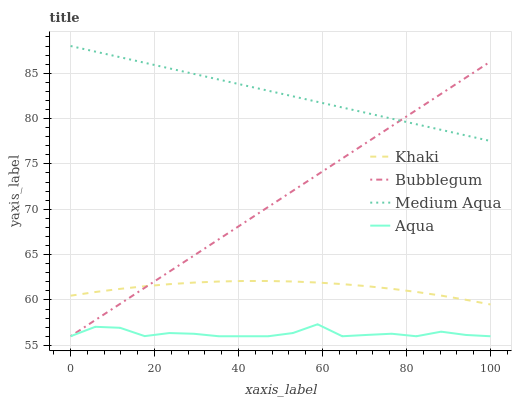Does Aqua have the minimum area under the curve?
Answer yes or no. Yes. Does Medium Aqua have the maximum area under the curve?
Answer yes or no. Yes. Does Khaki have the minimum area under the curve?
Answer yes or no. No. Does Khaki have the maximum area under the curve?
Answer yes or no. No. Is Medium Aqua the smoothest?
Answer yes or no. Yes. Is Aqua the roughest?
Answer yes or no. Yes. Is Khaki the smoothest?
Answer yes or no. No. Is Khaki the roughest?
Answer yes or no. No. Does Aqua have the lowest value?
Answer yes or no. Yes. Does Khaki have the lowest value?
Answer yes or no. No. Does Medium Aqua have the highest value?
Answer yes or no. Yes. Does Khaki have the highest value?
Answer yes or no. No. Is Khaki less than Medium Aqua?
Answer yes or no. Yes. Is Khaki greater than Aqua?
Answer yes or no. Yes. Does Bubblegum intersect Aqua?
Answer yes or no. Yes. Is Bubblegum less than Aqua?
Answer yes or no. No. Is Bubblegum greater than Aqua?
Answer yes or no. No. Does Khaki intersect Medium Aqua?
Answer yes or no. No. 